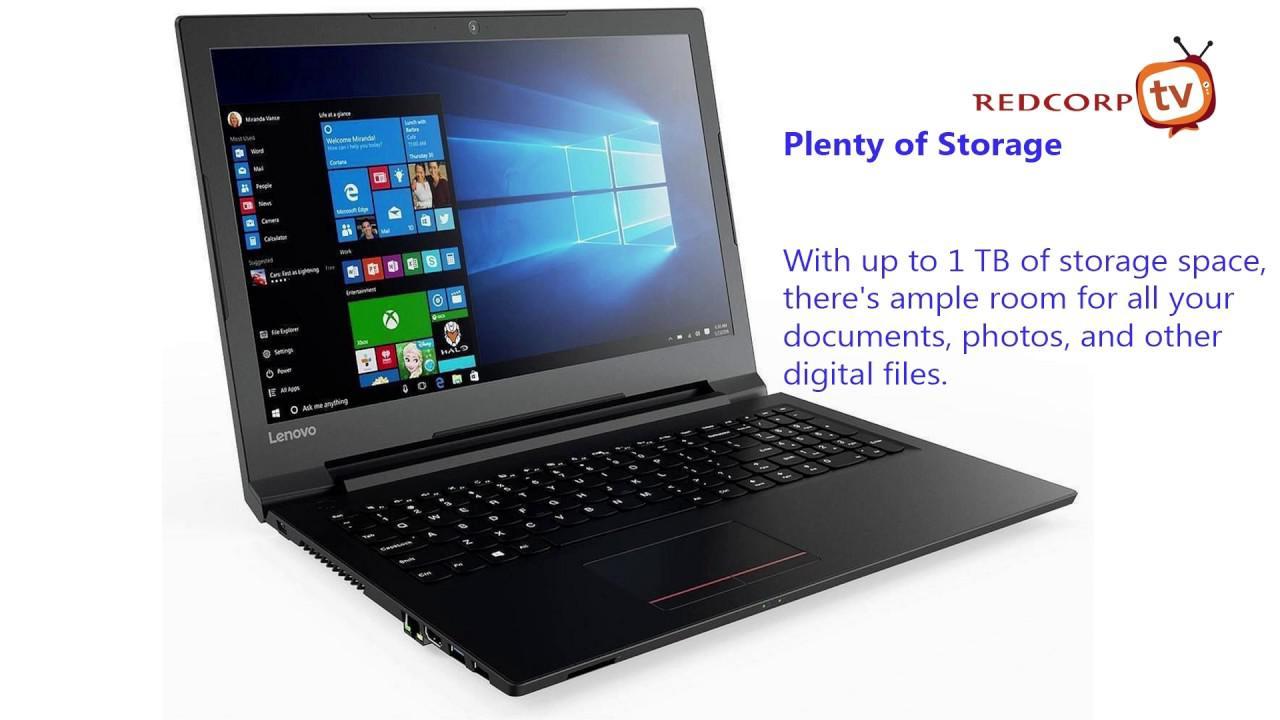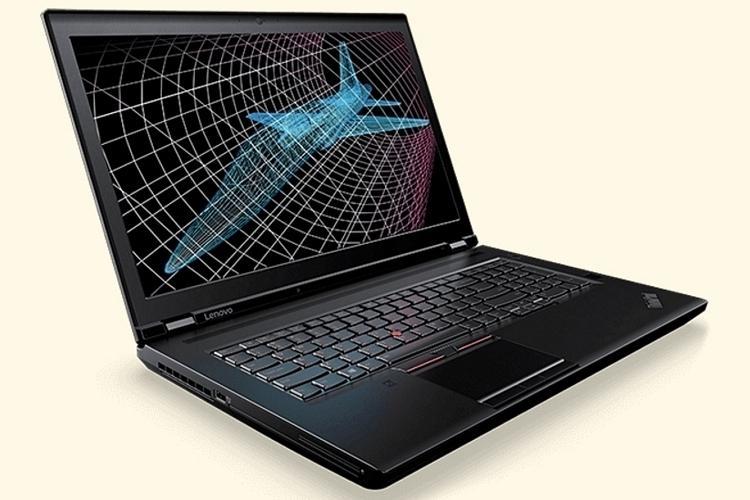The first image is the image on the left, the second image is the image on the right. Considering the images on both sides, is "The laptop on the left is facing to the left." valid? Answer yes or no. No. The first image is the image on the left, the second image is the image on the right. Analyze the images presented: Is the assertion "In at least one image there is a laptop with a blue screen and a sliver base near the keyboard." valid? Answer yes or no. No. 